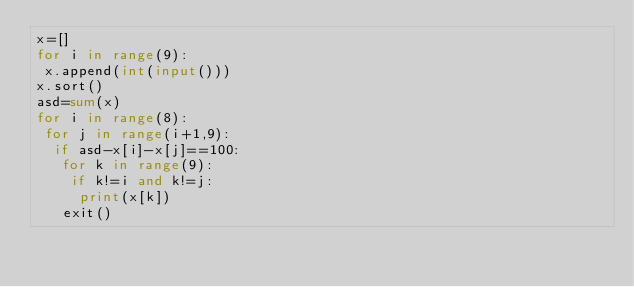<code> <loc_0><loc_0><loc_500><loc_500><_Python_>x=[]
for i in range(9):
 x.append(int(input()))
x.sort()
asd=sum(x)
for i in range(8):
 for j in range(i+1,9):
  if asd-x[i]-x[j]==100:
   for k in range(9):
    if k!=i and k!=j:
     print(x[k])
   exit()</code> 